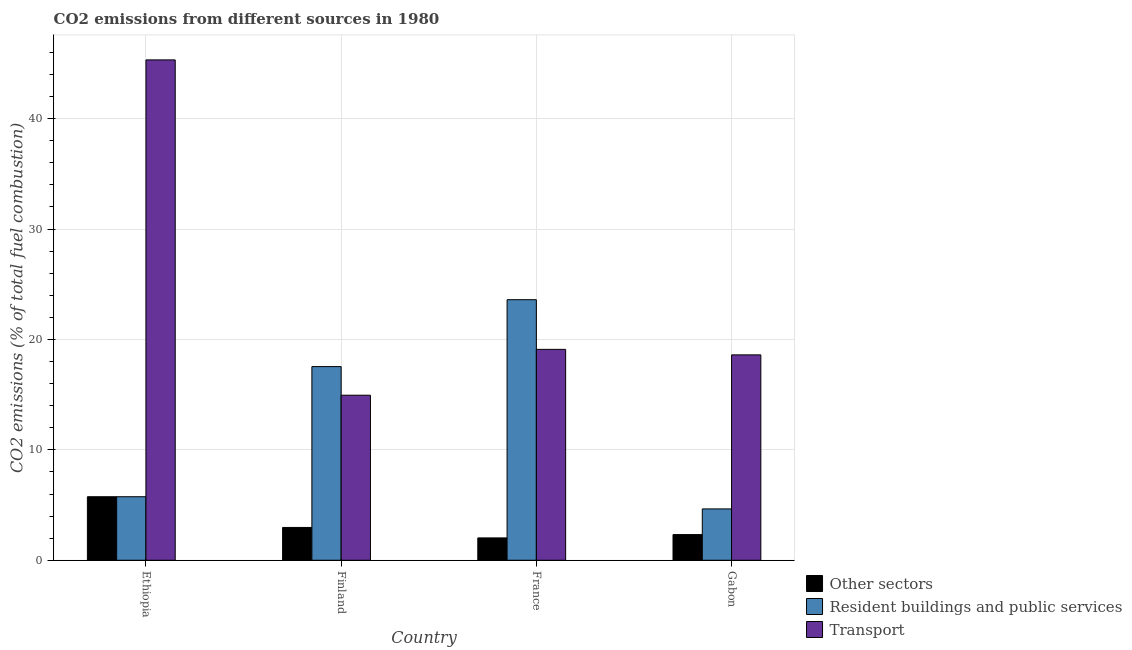Are the number of bars on each tick of the X-axis equal?
Your response must be concise. Yes. How many bars are there on the 4th tick from the left?
Give a very brief answer. 3. How many bars are there on the 2nd tick from the right?
Offer a terse response. 3. In how many cases, is the number of bars for a given country not equal to the number of legend labels?
Offer a terse response. 0. What is the percentage of co2 emissions from other sectors in Gabon?
Keep it short and to the point. 2.33. Across all countries, what is the maximum percentage of co2 emissions from resident buildings and public services?
Your answer should be very brief. 23.6. Across all countries, what is the minimum percentage of co2 emissions from other sectors?
Your response must be concise. 2.02. In which country was the percentage of co2 emissions from other sectors maximum?
Keep it short and to the point. Ethiopia. In which country was the percentage of co2 emissions from transport minimum?
Your response must be concise. Finland. What is the total percentage of co2 emissions from transport in the graph?
Offer a very short reply. 97.98. What is the difference between the percentage of co2 emissions from resident buildings and public services in France and that in Gabon?
Offer a very short reply. 18.95. What is the difference between the percentage of co2 emissions from resident buildings and public services in Gabon and the percentage of co2 emissions from other sectors in Finland?
Make the answer very short. 1.68. What is the average percentage of co2 emissions from transport per country?
Provide a succinct answer. 24.5. In how many countries, is the percentage of co2 emissions from resident buildings and public services greater than 20 %?
Your answer should be very brief. 1. What is the ratio of the percentage of co2 emissions from transport in Finland to that in France?
Your answer should be compact. 0.78. Is the percentage of co2 emissions from resident buildings and public services in Finland less than that in France?
Provide a short and direct response. Yes. Is the difference between the percentage of co2 emissions from resident buildings and public services in Finland and Gabon greater than the difference between the percentage of co2 emissions from other sectors in Finland and Gabon?
Provide a succinct answer. Yes. What is the difference between the highest and the second highest percentage of co2 emissions from other sectors?
Give a very brief answer. 2.78. What is the difference between the highest and the lowest percentage of co2 emissions from other sectors?
Your response must be concise. 3.73. In how many countries, is the percentage of co2 emissions from resident buildings and public services greater than the average percentage of co2 emissions from resident buildings and public services taken over all countries?
Provide a succinct answer. 2. Is the sum of the percentage of co2 emissions from transport in Finland and France greater than the maximum percentage of co2 emissions from resident buildings and public services across all countries?
Ensure brevity in your answer.  Yes. What does the 1st bar from the left in Ethiopia represents?
Provide a succinct answer. Other sectors. What does the 2nd bar from the right in Ethiopia represents?
Provide a short and direct response. Resident buildings and public services. Is it the case that in every country, the sum of the percentage of co2 emissions from other sectors and percentage of co2 emissions from resident buildings and public services is greater than the percentage of co2 emissions from transport?
Give a very brief answer. No. How many bars are there?
Your answer should be very brief. 12. Are the values on the major ticks of Y-axis written in scientific E-notation?
Offer a very short reply. No. Does the graph contain any zero values?
Offer a terse response. No. Where does the legend appear in the graph?
Ensure brevity in your answer.  Bottom right. How many legend labels are there?
Provide a short and direct response. 3. How are the legend labels stacked?
Offer a terse response. Vertical. What is the title of the graph?
Provide a short and direct response. CO2 emissions from different sources in 1980. Does "Unemployment benefits" appear as one of the legend labels in the graph?
Your answer should be compact. No. What is the label or title of the Y-axis?
Your response must be concise. CO2 emissions (% of total fuel combustion). What is the CO2 emissions (% of total fuel combustion) of Other sectors in Ethiopia?
Offer a very short reply. 5.76. What is the CO2 emissions (% of total fuel combustion) of Resident buildings and public services in Ethiopia?
Make the answer very short. 5.76. What is the CO2 emissions (% of total fuel combustion) of Transport in Ethiopia?
Offer a terse response. 45.32. What is the CO2 emissions (% of total fuel combustion) in Other sectors in Finland?
Give a very brief answer. 2.97. What is the CO2 emissions (% of total fuel combustion) of Resident buildings and public services in Finland?
Your answer should be compact. 17.54. What is the CO2 emissions (% of total fuel combustion) of Transport in Finland?
Offer a terse response. 14.95. What is the CO2 emissions (% of total fuel combustion) in Other sectors in France?
Provide a succinct answer. 2.02. What is the CO2 emissions (% of total fuel combustion) of Resident buildings and public services in France?
Keep it short and to the point. 23.6. What is the CO2 emissions (% of total fuel combustion) of Transport in France?
Offer a very short reply. 19.1. What is the CO2 emissions (% of total fuel combustion) of Other sectors in Gabon?
Your response must be concise. 2.33. What is the CO2 emissions (% of total fuel combustion) of Resident buildings and public services in Gabon?
Your answer should be very brief. 4.65. What is the CO2 emissions (% of total fuel combustion) in Transport in Gabon?
Provide a succinct answer. 18.6. Across all countries, what is the maximum CO2 emissions (% of total fuel combustion) in Other sectors?
Keep it short and to the point. 5.76. Across all countries, what is the maximum CO2 emissions (% of total fuel combustion) of Resident buildings and public services?
Your answer should be compact. 23.6. Across all countries, what is the maximum CO2 emissions (% of total fuel combustion) of Transport?
Provide a succinct answer. 45.32. Across all countries, what is the minimum CO2 emissions (% of total fuel combustion) of Other sectors?
Give a very brief answer. 2.02. Across all countries, what is the minimum CO2 emissions (% of total fuel combustion) of Resident buildings and public services?
Your answer should be very brief. 4.65. Across all countries, what is the minimum CO2 emissions (% of total fuel combustion) in Transport?
Offer a very short reply. 14.95. What is the total CO2 emissions (% of total fuel combustion) of Other sectors in the graph?
Your answer should be compact. 13.08. What is the total CO2 emissions (% of total fuel combustion) of Resident buildings and public services in the graph?
Your response must be concise. 51.55. What is the total CO2 emissions (% of total fuel combustion) in Transport in the graph?
Offer a very short reply. 97.98. What is the difference between the CO2 emissions (% of total fuel combustion) of Other sectors in Ethiopia and that in Finland?
Your answer should be compact. 2.78. What is the difference between the CO2 emissions (% of total fuel combustion) of Resident buildings and public services in Ethiopia and that in Finland?
Offer a very short reply. -11.79. What is the difference between the CO2 emissions (% of total fuel combustion) in Transport in Ethiopia and that in Finland?
Offer a very short reply. 30.37. What is the difference between the CO2 emissions (% of total fuel combustion) of Other sectors in Ethiopia and that in France?
Your response must be concise. 3.73. What is the difference between the CO2 emissions (% of total fuel combustion) of Resident buildings and public services in Ethiopia and that in France?
Provide a short and direct response. -17.85. What is the difference between the CO2 emissions (% of total fuel combustion) of Transport in Ethiopia and that in France?
Give a very brief answer. 26.22. What is the difference between the CO2 emissions (% of total fuel combustion) in Other sectors in Ethiopia and that in Gabon?
Keep it short and to the point. 3.43. What is the difference between the CO2 emissions (% of total fuel combustion) of Resident buildings and public services in Ethiopia and that in Gabon?
Provide a succinct answer. 1.1. What is the difference between the CO2 emissions (% of total fuel combustion) in Transport in Ethiopia and that in Gabon?
Your response must be concise. 26.72. What is the difference between the CO2 emissions (% of total fuel combustion) in Other sectors in Finland and that in France?
Offer a terse response. 0.95. What is the difference between the CO2 emissions (% of total fuel combustion) in Resident buildings and public services in Finland and that in France?
Make the answer very short. -6.06. What is the difference between the CO2 emissions (% of total fuel combustion) in Transport in Finland and that in France?
Your answer should be compact. -4.15. What is the difference between the CO2 emissions (% of total fuel combustion) of Other sectors in Finland and that in Gabon?
Offer a terse response. 0.65. What is the difference between the CO2 emissions (% of total fuel combustion) of Resident buildings and public services in Finland and that in Gabon?
Provide a succinct answer. 12.89. What is the difference between the CO2 emissions (% of total fuel combustion) in Transport in Finland and that in Gabon?
Provide a succinct answer. -3.65. What is the difference between the CO2 emissions (% of total fuel combustion) of Other sectors in France and that in Gabon?
Provide a succinct answer. -0.3. What is the difference between the CO2 emissions (% of total fuel combustion) in Resident buildings and public services in France and that in Gabon?
Provide a succinct answer. 18.95. What is the difference between the CO2 emissions (% of total fuel combustion) in Transport in France and that in Gabon?
Your answer should be very brief. 0.5. What is the difference between the CO2 emissions (% of total fuel combustion) of Other sectors in Ethiopia and the CO2 emissions (% of total fuel combustion) of Resident buildings and public services in Finland?
Give a very brief answer. -11.79. What is the difference between the CO2 emissions (% of total fuel combustion) in Other sectors in Ethiopia and the CO2 emissions (% of total fuel combustion) in Transport in Finland?
Your answer should be compact. -9.2. What is the difference between the CO2 emissions (% of total fuel combustion) in Resident buildings and public services in Ethiopia and the CO2 emissions (% of total fuel combustion) in Transport in Finland?
Your answer should be compact. -9.2. What is the difference between the CO2 emissions (% of total fuel combustion) of Other sectors in Ethiopia and the CO2 emissions (% of total fuel combustion) of Resident buildings and public services in France?
Provide a succinct answer. -17.85. What is the difference between the CO2 emissions (% of total fuel combustion) in Other sectors in Ethiopia and the CO2 emissions (% of total fuel combustion) in Transport in France?
Your answer should be compact. -13.35. What is the difference between the CO2 emissions (% of total fuel combustion) of Resident buildings and public services in Ethiopia and the CO2 emissions (% of total fuel combustion) of Transport in France?
Provide a short and direct response. -13.35. What is the difference between the CO2 emissions (% of total fuel combustion) in Other sectors in Ethiopia and the CO2 emissions (% of total fuel combustion) in Resident buildings and public services in Gabon?
Offer a very short reply. 1.1. What is the difference between the CO2 emissions (% of total fuel combustion) of Other sectors in Ethiopia and the CO2 emissions (% of total fuel combustion) of Transport in Gabon?
Your response must be concise. -12.85. What is the difference between the CO2 emissions (% of total fuel combustion) in Resident buildings and public services in Ethiopia and the CO2 emissions (% of total fuel combustion) in Transport in Gabon?
Make the answer very short. -12.85. What is the difference between the CO2 emissions (% of total fuel combustion) in Other sectors in Finland and the CO2 emissions (% of total fuel combustion) in Resident buildings and public services in France?
Your answer should be compact. -20.63. What is the difference between the CO2 emissions (% of total fuel combustion) of Other sectors in Finland and the CO2 emissions (% of total fuel combustion) of Transport in France?
Ensure brevity in your answer.  -16.13. What is the difference between the CO2 emissions (% of total fuel combustion) in Resident buildings and public services in Finland and the CO2 emissions (% of total fuel combustion) in Transport in France?
Your answer should be compact. -1.56. What is the difference between the CO2 emissions (% of total fuel combustion) of Other sectors in Finland and the CO2 emissions (% of total fuel combustion) of Resident buildings and public services in Gabon?
Your answer should be compact. -1.68. What is the difference between the CO2 emissions (% of total fuel combustion) of Other sectors in Finland and the CO2 emissions (% of total fuel combustion) of Transport in Gabon?
Make the answer very short. -15.63. What is the difference between the CO2 emissions (% of total fuel combustion) of Resident buildings and public services in Finland and the CO2 emissions (% of total fuel combustion) of Transport in Gabon?
Offer a terse response. -1.06. What is the difference between the CO2 emissions (% of total fuel combustion) of Other sectors in France and the CO2 emissions (% of total fuel combustion) of Resident buildings and public services in Gabon?
Offer a very short reply. -2.63. What is the difference between the CO2 emissions (% of total fuel combustion) in Other sectors in France and the CO2 emissions (% of total fuel combustion) in Transport in Gabon?
Provide a succinct answer. -16.58. What is the difference between the CO2 emissions (% of total fuel combustion) in Resident buildings and public services in France and the CO2 emissions (% of total fuel combustion) in Transport in Gabon?
Your answer should be compact. 5. What is the average CO2 emissions (% of total fuel combustion) of Other sectors per country?
Your response must be concise. 3.27. What is the average CO2 emissions (% of total fuel combustion) of Resident buildings and public services per country?
Offer a terse response. 12.89. What is the average CO2 emissions (% of total fuel combustion) in Transport per country?
Make the answer very short. 24.5. What is the difference between the CO2 emissions (% of total fuel combustion) in Other sectors and CO2 emissions (% of total fuel combustion) in Resident buildings and public services in Ethiopia?
Provide a succinct answer. 0. What is the difference between the CO2 emissions (% of total fuel combustion) of Other sectors and CO2 emissions (% of total fuel combustion) of Transport in Ethiopia?
Make the answer very short. -39.57. What is the difference between the CO2 emissions (% of total fuel combustion) in Resident buildings and public services and CO2 emissions (% of total fuel combustion) in Transport in Ethiopia?
Give a very brief answer. -39.57. What is the difference between the CO2 emissions (% of total fuel combustion) of Other sectors and CO2 emissions (% of total fuel combustion) of Resident buildings and public services in Finland?
Your answer should be compact. -14.57. What is the difference between the CO2 emissions (% of total fuel combustion) in Other sectors and CO2 emissions (% of total fuel combustion) in Transport in Finland?
Your response must be concise. -11.98. What is the difference between the CO2 emissions (% of total fuel combustion) of Resident buildings and public services and CO2 emissions (% of total fuel combustion) of Transport in Finland?
Your answer should be very brief. 2.59. What is the difference between the CO2 emissions (% of total fuel combustion) of Other sectors and CO2 emissions (% of total fuel combustion) of Resident buildings and public services in France?
Give a very brief answer. -21.58. What is the difference between the CO2 emissions (% of total fuel combustion) in Other sectors and CO2 emissions (% of total fuel combustion) in Transport in France?
Offer a terse response. -17.08. What is the difference between the CO2 emissions (% of total fuel combustion) of Resident buildings and public services and CO2 emissions (% of total fuel combustion) of Transport in France?
Ensure brevity in your answer.  4.5. What is the difference between the CO2 emissions (% of total fuel combustion) in Other sectors and CO2 emissions (% of total fuel combustion) in Resident buildings and public services in Gabon?
Offer a very short reply. -2.33. What is the difference between the CO2 emissions (% of total fuel combustion) of Other sectors and CO2 emissions (% of total fuel combustion) of Transport in Gabon?
Your answer should be compact. -16.28. What is the difference between the CO2 emissions (% of total fuel combustion) in Resident buildings and public services and CO2 emissions (% of total fuel combustion) in Transport in Gabon?
Offer a terse response. -13.95. What is the ratio of the CO2 emissions (% of total fuel combustion) in Other sectors in Ethiopia to that in Finland?
Offer a very short reply. 1.94. What is the ratio of the CO2 emissions (% of total fuel combustion) in Resident buildings and public services in Ethiopia to that in Finland?
Your answer should be very brief. 0.33. What is the ratio of the CO2 emissions (% of total fuel combustion) of Transport in Ethiopia to that in Finland?
Your answer should be compact. 3.03. What is the ratio of the CO2 emissions (% of total fuel combustion) in Other sectors in Ethiopia to that in France?
Your response must be concise. 2.84. What is the ratio of the CO2 emissions (% of total fuel combustion) of Resident buildings and public services in Ethiopia to that in France?
Provide a short and direct response. 0.24. What is the ratio of the CO2 emissions (% of total fuel combustion) in Transport in Ethiopia to that in France?
Offer a terse response. 2.37. What is the ratio of the CO2 emissions (% of total fuel combustion) in Other sectors in Ethiopia to that in Gabon?
Provide a succinct answer. 2.47. What is the ratio of the CO2 emissions (% of total fuel combustion) of Resident buildings and public services in Ethiopia to that in Gabon?
Provide a succinct answer. 1.24. What is the ratio of the CO2 emissions (% of total fuel combustion) in Transport in Ethiopia to that in Gabon?
Your answer should be very brief. 2.44. What is the ratio of the CO2 emissions (% of total fuel combustion) of Other sectors in Finland to that in France?
Provide a short and direct response. 1.47. What is the ratio of the CO2 emissions (% of total fuel combustion) in Resident buildings and public services in Finland to that in France?
Your response must be concise. 0.74. What is the ratio of the CO2 emissions (% of total fuel combustion) in Transport in Finland to that in France?
Offer a terse response. 0.78. What is the ratio of the CO2 emissions (% of total fuel combustion) in Other sectors in Finland to that in Gabon?
Your response must be concise. 1.28. What is the ratio of the CO2 emissions (% of total fuel combustion) of Resident buildings and public services in Finland to that in Gabon?
Provide a succinct answer. 3.77. What is the ratio of the CO2 emissions (% of total fuel combustion) of Transport in Finland to that in Gabon?
Offer a terse response. 0.8. What is the ratio of the CO2 emissions (% of total fuel combustion) in Other sectors in France to that in Gabon?
Make the answer very short. 0.87. What is the ratio of the CO2 emissions (% of total fuel combustion) of Resident buildings and public services in France to that in Gabon?
Provide a succinct answer. 5.07. What is the ratio of the CO2 emissions (% of total fuel combustion) in Transport in France to that in Gabon?
Give a very brief answer. 1.03. What is the difference between the highest and the second highest CO2 emissions (% of total fuel combustion) of Other sectors?
Keep it short and to the point. 2.78. What is the difference between the highest and the second highest CO2 emissions (% of total fuel combustion) of Resident buildings and public services?
Ensure brevity in your answer.  6.06. What is the difference between the highest and the second highest CO2 emissions (% of total fuel combustion) of Transport?
Make the answer very short. 26.22. What is the difference between the highest and the lowest CO2 emissions (% of total fuel combustion) of Other sectors?
Your response must be concise. 3.73. What is the difference between the highest and the lowest CO2 emissions (% of total fuel combustion) in Resident buildings and public services?
Your response must be concise. 18.95. What is the difference between the highest and the lowest CO2 emissions (% of total fuel combustion) of Transport?
Your response must be concise. 30.37. 